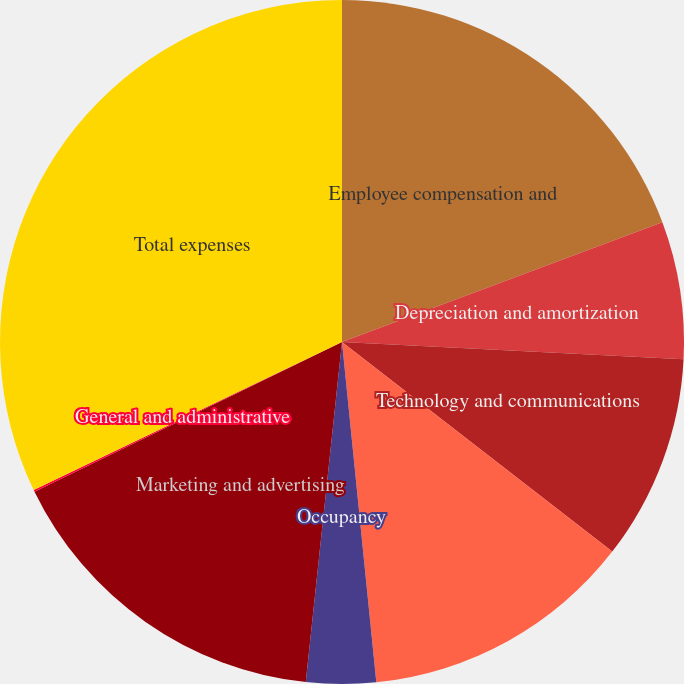Convert chart to OTSL. <chart><loc_0><loc_0><loc_500><loc_500><pie_chart><fcel>Employee compensation and<fcel>Depreciation and amortization<fcel>Technology and communications<fcel>Professional and consulting<fcel>Occupancy<fcel>Marketing and advertising<fcel>General and administrative<fcel>Total expenses<nl><fcel>19.31%<fcel>6.49%<fcel>9.7%<fcel>12.9%<fcel>3.29%<fcel>16.1%<fcel>0.09%<fcel>32.12%<nl></chart> 